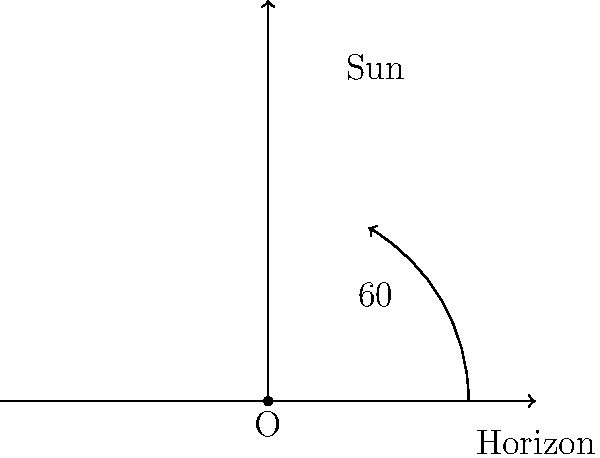You're enjoying a relaxing evening at the beach, but you're worried about missing your favorite TV show. Looking at the sun's position in the sky, you estimate it's about 60° above the horizon. Assuming the sun moves at a constant rate of 15° per hour, approximately how much time do you have left before sunset? Let's break this down step-by-step:

1) First, recall that the sun appears to move 15° per hour across the sky. This is because:
   $$ \frac{360°}{24 \text{ hours}} = 15° \text{ per hour} $$

2) The sun is currently 60° above the horizon. At sunset, it will be at 0°.

3) So, we need to calculate how long it will take for the sun to move 60°:
   $$ \text{Time} = \frac{\text{Angle to move}}{\text{Rate of movement}} $$

4) Plugging in our values:
   $$ \text{Time} = \frac{60°}{15° \text{ per hour}} = 4 \text{ hours} $$

Therefore, you have approximately 4 hours before sunset.
Answer: 4 hours 